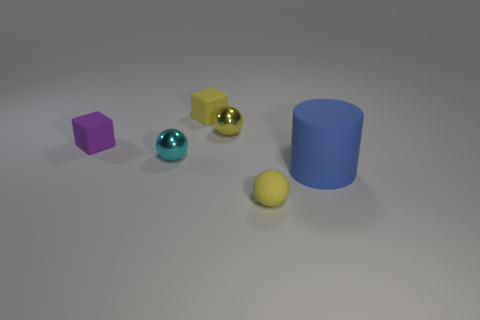Subtract all metallic balls. How many balls are left? 1 Subtract all blue cylinders. How many yellow balls are left? 2 Add 1 purple rubber objects. How many objects exist? 7 Subtract all cubes. How many objects are left? 4 Add 2 yellow metallic objects. How many yellow metallic objects are left? 3 Add 4 blue objects. How many blue objects exist? 5 Subtract 0 brown blocks. How many objects are left? 6 Subtract all brown balls. Subtract all blue blocks. How many balls are left? 3 Subtract all cubes. Subtract all small yellow rubber cubes. How many objects are left? 3 